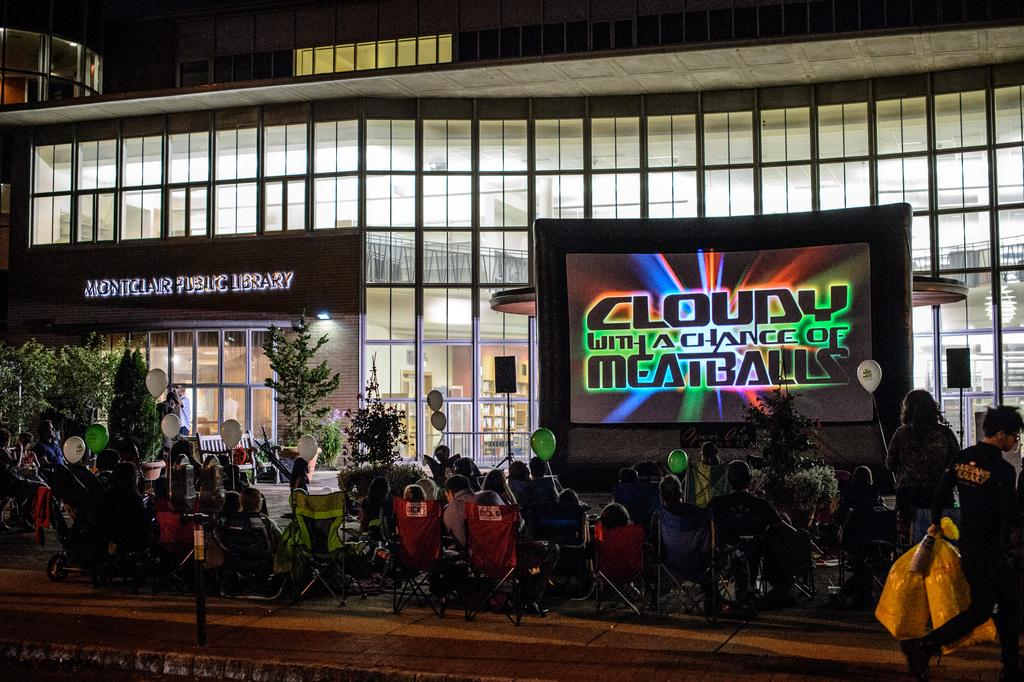What are the people in the image doing? The people in the image are sitting on chairs. What decorative items can be seen in the image? There are balloons visible in the image. What might be used for displaying information or visuals in the image? There is a screen in the image. What type of structure is present in the image? There is a building in the image. What type of vegetation is on the left side of the image? Trees are present on the left side of the image. What type of tin can be seen in the image? There is no tin present in the image. What smell is associated with the image? The image does not convey any specific smell. 